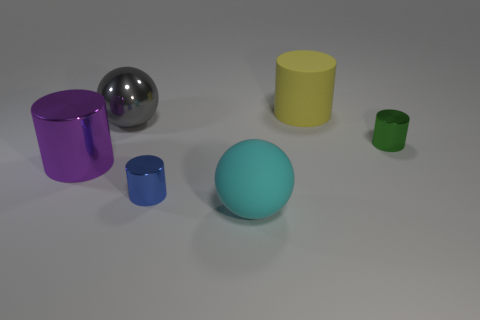Add 2 large blue objects. How many objects exist? 8 Subtract all spheres. How many objects are left? 4 Add 3 green shiny objects. How many green shiny objects are left? 4 Add 1 tiny purple metal cubes. How many tiny purple metal cubes exist? 1 Subtract 0 brown spheres. How many objects are left? 6 Subtract all large blue metallic cylinders. Subtract all large rubber cylinders. How many objects are left? 5 